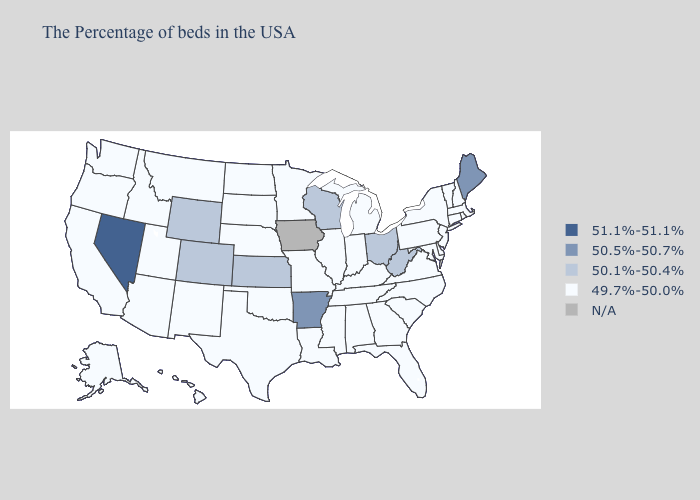Name the states that have a value in the range 50.5%-50.7%?
Concise answer only. Maine, Arkansas. Does Nevada have the lowest value in the West?
Give a very brief answer. No. Does Utah have the highest value in the USA?
Quick response, please. No. What is the value of Wyoming?
Keep it brief. 50.1%-50.4%. What is the value of Oklahoma?
Keep it brief. 49.7%-50.0%. What is the lowest value in the USA?
Keep it brief. 49.7%-50.0%. Name the states that have a value in the range 49.7%-50.0%?
Concise answer only. Massachusetts, Rhode Island, New Hampshire, Vermont, Connecticut, New York, New Jersey, Delaware, Maryland, Pennsylvania, Virginia, North Carolina, South Carolina, Florida, Georgia, Michigan, Kentucky, Indiana, Alabama, Tennessee, Illinois, Mississippi, Louisiana, Missouri, Minnesota, Nebraska, Oklahoma, Texas, South Dakota, North Dakota, New Mexico, Utah, Montana, Arizona, Idaho, California, Washington, Oregon, Alaska, Hawaii. Name the states that have a value in the range 50.1%-50.4%?
Concise answer only. West Virginia, Ohio, Wisconsin, Kansas, Wyoming, Colorado. What is the value of Washington?
Keep it brief. 49.7%-50.0%. What is the value of West Virginia?
Give a very brief answer. 50.1%-50.4%. Does the map have missing data?
Short answer required. Yes. Which states have the lowest value in the West?
Write a very short answer. New Mexico, Utah, Montana, Arizona, Idaho, California, Washington, Oregon, Alaska, Hawaii. Name the states that have a value in the range N/A?
Answer briefly. Iowa. Which states have the highest value in the USA?
Write a very short answer. Nevada. 